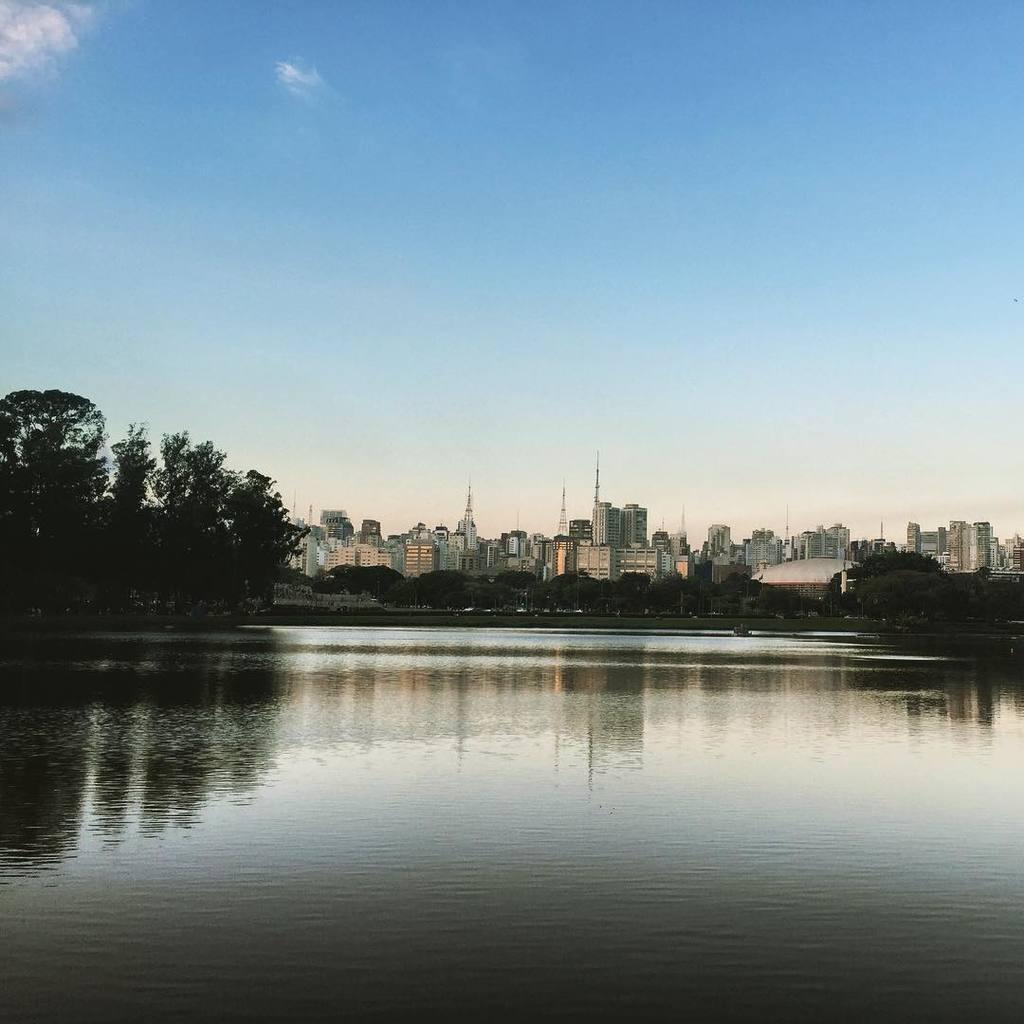Describe this image in one or two sentences. In this picture we can see a river. There are many buildings and trees in the middle of the picture. The sky is blue. 